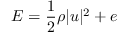<formula> <loc_0><loc_0><loc_500><loc_500>E = \frac { 1 } { 2 } \rho | u | ^ { 2 } + e</formula> 